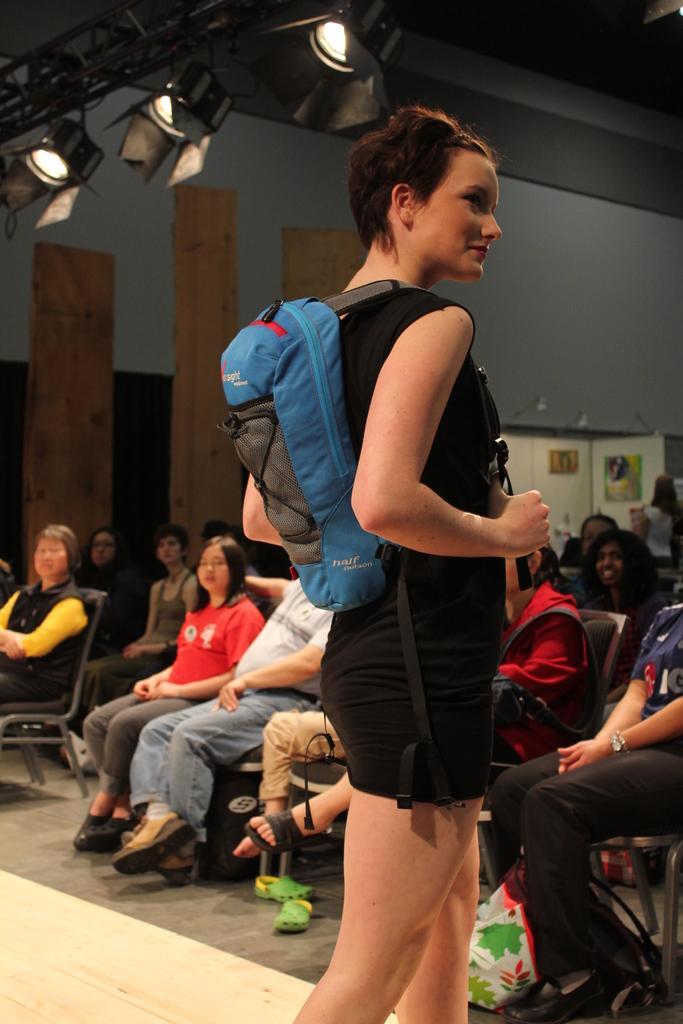In one or two sentences, can you explain what this image depicts? Here I can see a woman wearing black color dress, a bag, standing facing towards the right side. In the background there are many people sitting on the chairs and looking at this woman. At the top there are few lights attached to the metal rods. In the background there is a wall. 